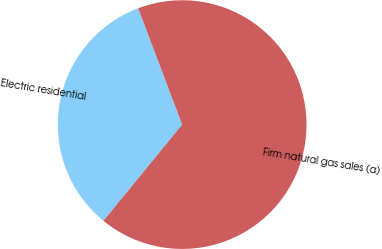<chart> <loc_0><loc_0><loc_500><loc_500><pie_chart><fcel>Electric residential<fcel>Firm natural gas sales (a)<nl><fcel>33.33%<fcel>66.67%<nl></chart> 